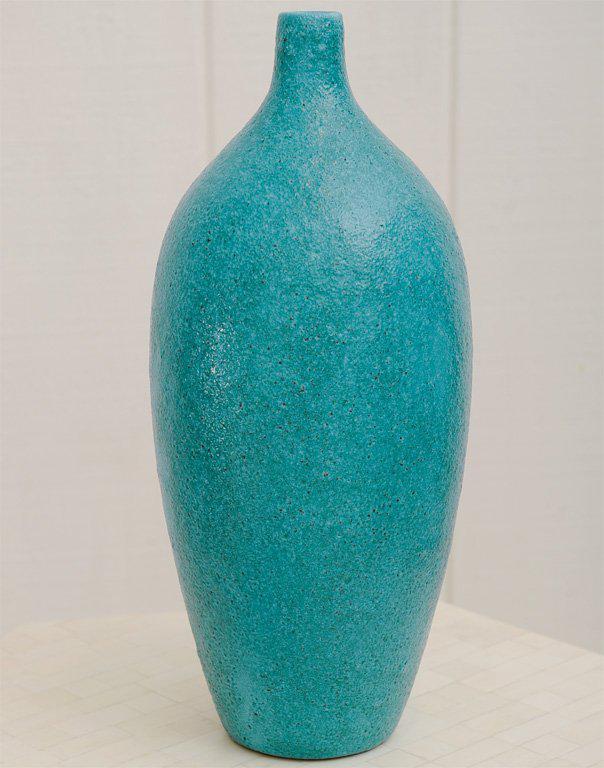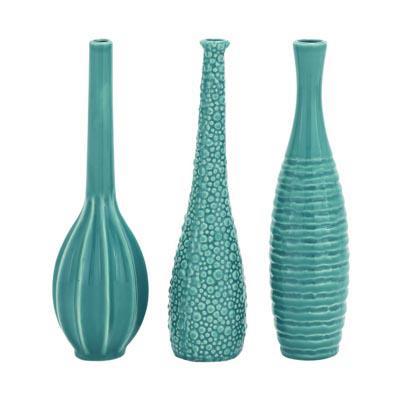The first image is the image on the left, the second image is the image on the right. Analyze the images presented: Is the assertion "An image shows three turquoise blue vases." valid? Answer yes or no. Yes. The first image is the image on the left, the second image is the image on the right. For the images shown, is this caption "Four pieces of turquoise blue pottery are shown." true? Answer yes or no. Yes. 